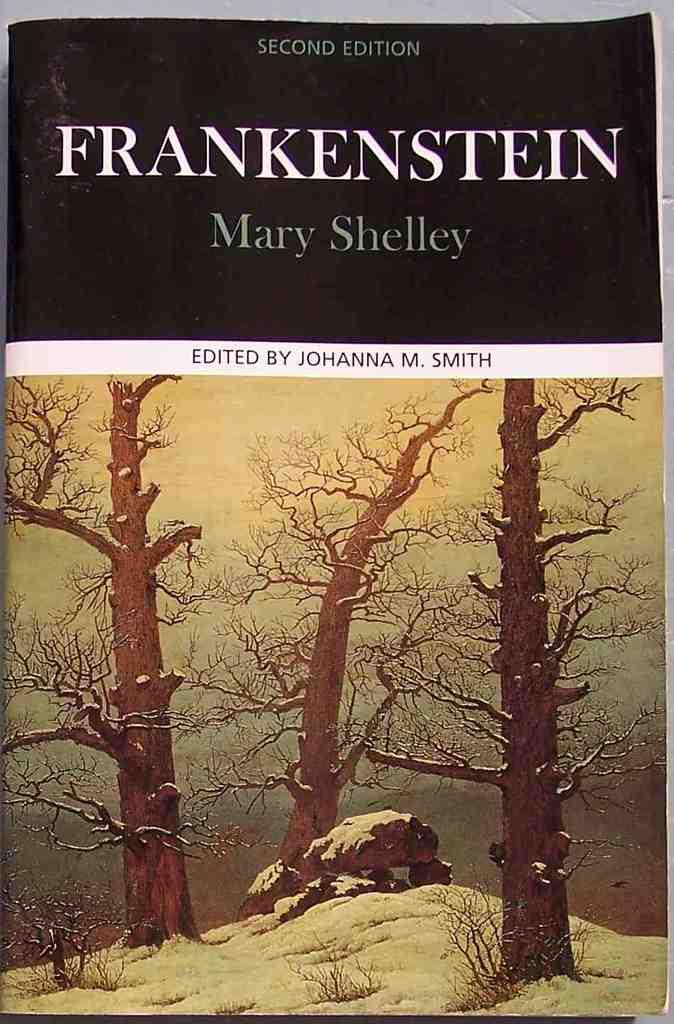Provide a one-sentence caption for the provided image. Frankenstein by Mary Shelly is an interesting read, full of suspense. 